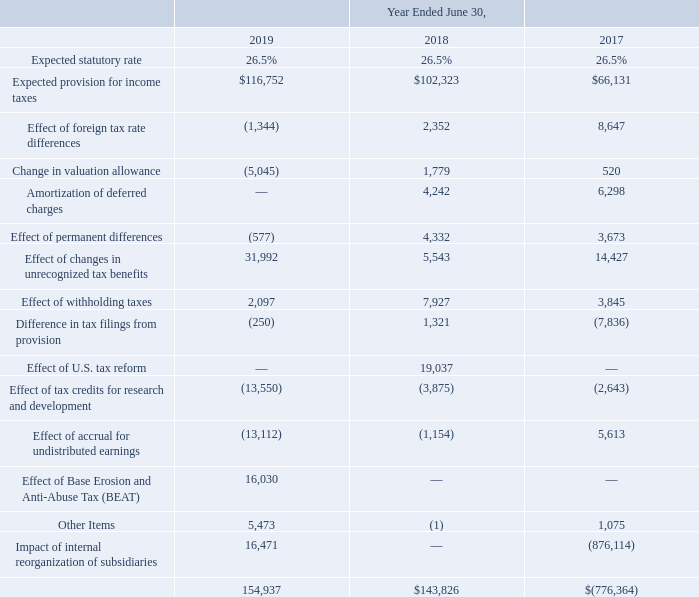A reconciliation of the combined Canadian federal and provincial income tax rate with our effective income tax rate is as follows:
In Fiscal 2019, 2018 and 2017, respectively, substantially all the tax rate differential for international jurisdictions was driven by earnings in the United States.
The effective tax rate decreased to a provision of 35.2% for the year ended June 30, 2019, compared to 37.2% for the year ended June 30, 2018. The increase in tax expense of $11.1 million was primarily due to the increase in net income taxed at foreign rates of $10.7 million, an increase of $26.4 million in reserves for unrecognized tax benefits, an increase of $16.1 million arising on the introduction of BEAT in Fiscal 2019, and an increase of $16.3 million relating to the tax impact of internal reorganizations of subsidiaries, partially offset by a the reversal of accruals for undistributed United States earnings of $14.8 million, the Fiscal 2018 impact of United States tax reform of $19.0 million which did not recur in Fiscal 2019, an increase in tax credits for research and development of $9.7 million, an increase of $6.8 million in the release of valuation allowance, a decrease of $5.8 million in the impact of withholding taxes in Fiscal 2019. The remainder of the difference was due to normal course movements and non-material items.
In July 2016, we implemented a reorganization of our subsidiaries worldwide with the view to continuing to enhance operational and administrative efficiencies through further consolidated ownership, management, and development of our intellectual property (IP) in Canada, continuing to reduce the number of entities in our group and working towards our objective of having a single operating legal entity in each jurisdiction. A significant tax benefit of $876.1 million, associated primarily with the recognition of a net deferred tax asset arising from the entry of the IP into Canada, was recognized in the first quarter of Fiscal 2017. For more information relating to this, please refer to our Annual Report on Form 10-K for the year ended June 30, 2017.
As of June 30, 2019, we have approximately $242.3 million of domestic non-capital loss carryforwards. In addition, we have $387.6 million of foreign non-capital loss carryforwards of which $53.8 million have no expiry date. The remainder of the domestic and foreign losses expires between 2020 and 2039. In addition, investment tax credits of $58.6 million will expire between 2020 and 2039.
What does the table represent? Reconciliation of the combined canadian federal and provincial income tax rate with our effective income tax rate. How much domestic non-capital loss carryforwards are there as of June 30, 2019? Approximately $242.3 million. What fiscal years are included in the table? 2019, 2018, 2017. What is the difference in Expected provision for income taxes from fiscal year 2018 to 2019?
Answer scale should be: thousand. 116,752-102,323
Answer: 14429. What is the average annual Effect of foreign tax rate differences? 
Answer scale should be: thousand. (-1,344+2,352+8,647)/3
Answer: 3218.33. What is the difference in the Effect of changes in unrecognized tax benefits from fiscal year 2017 to 2019?
Answer scale should be: thousand. 31,992-14,427
Answer: 17565. 